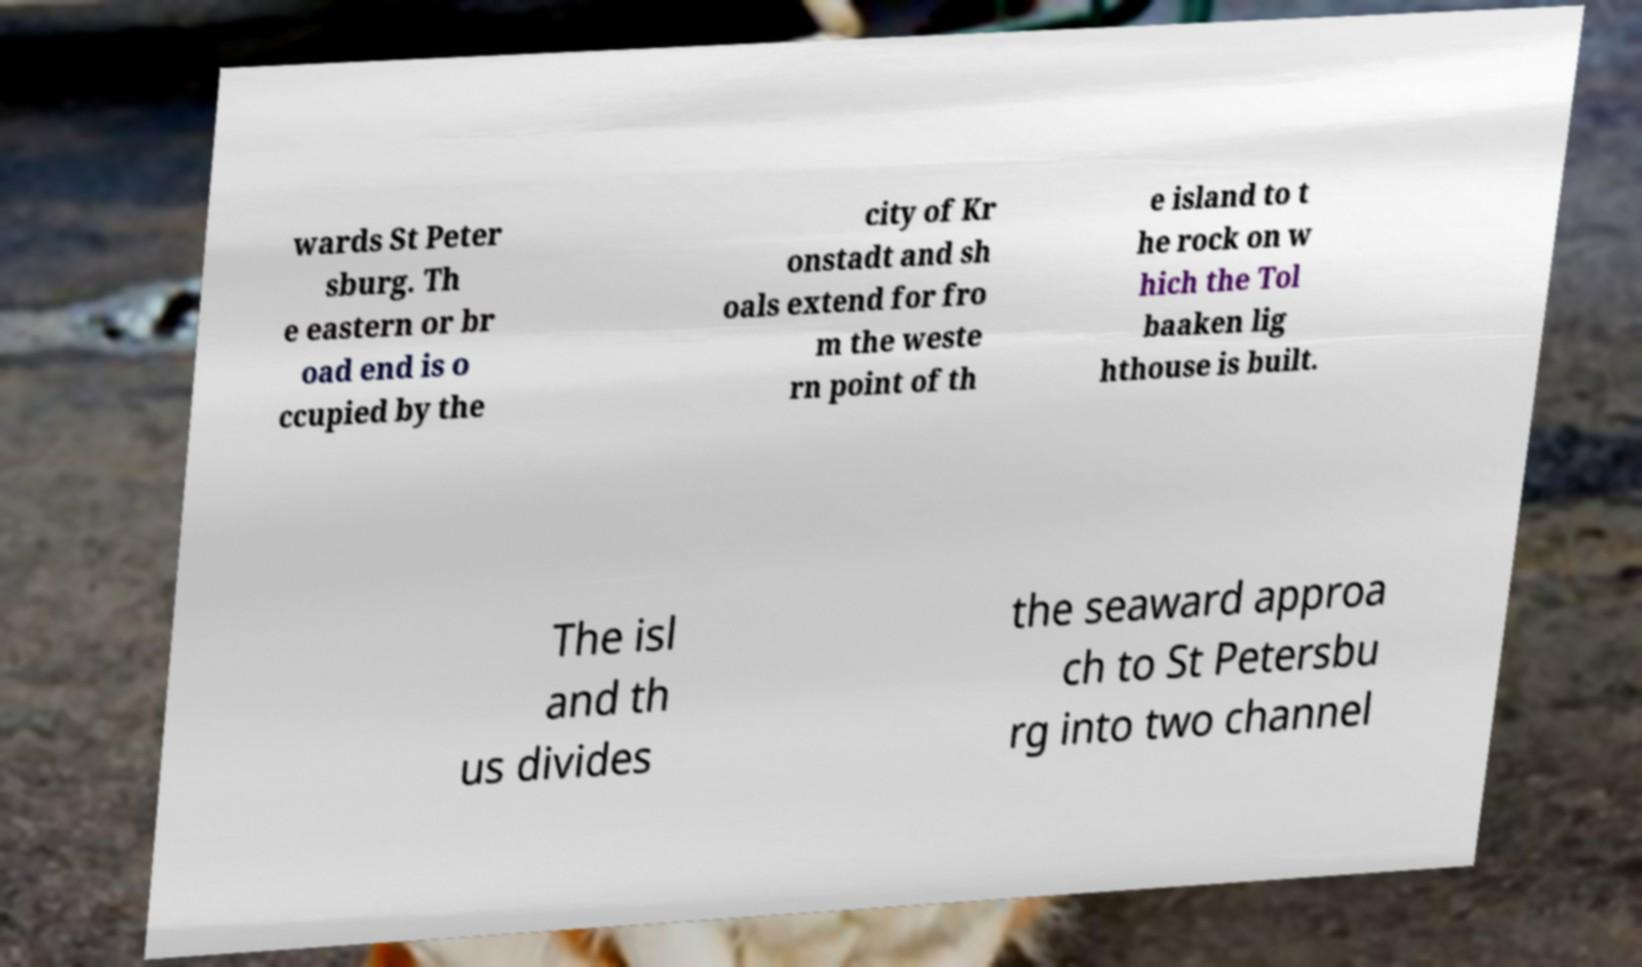There's text embedded in this image that I need extracted. Can you transcribe it verbatim? wards St Peter sburg. Th e eastern or br oad end is o ccupied by the city of Kr onstadt and sh oals extend for fro m the weste rn point of th e island to t he rock on w hich the Tol baaken lig hthouse is built. The isl and th us divides the seaward approa ch to St Petersbu rg into two channel 